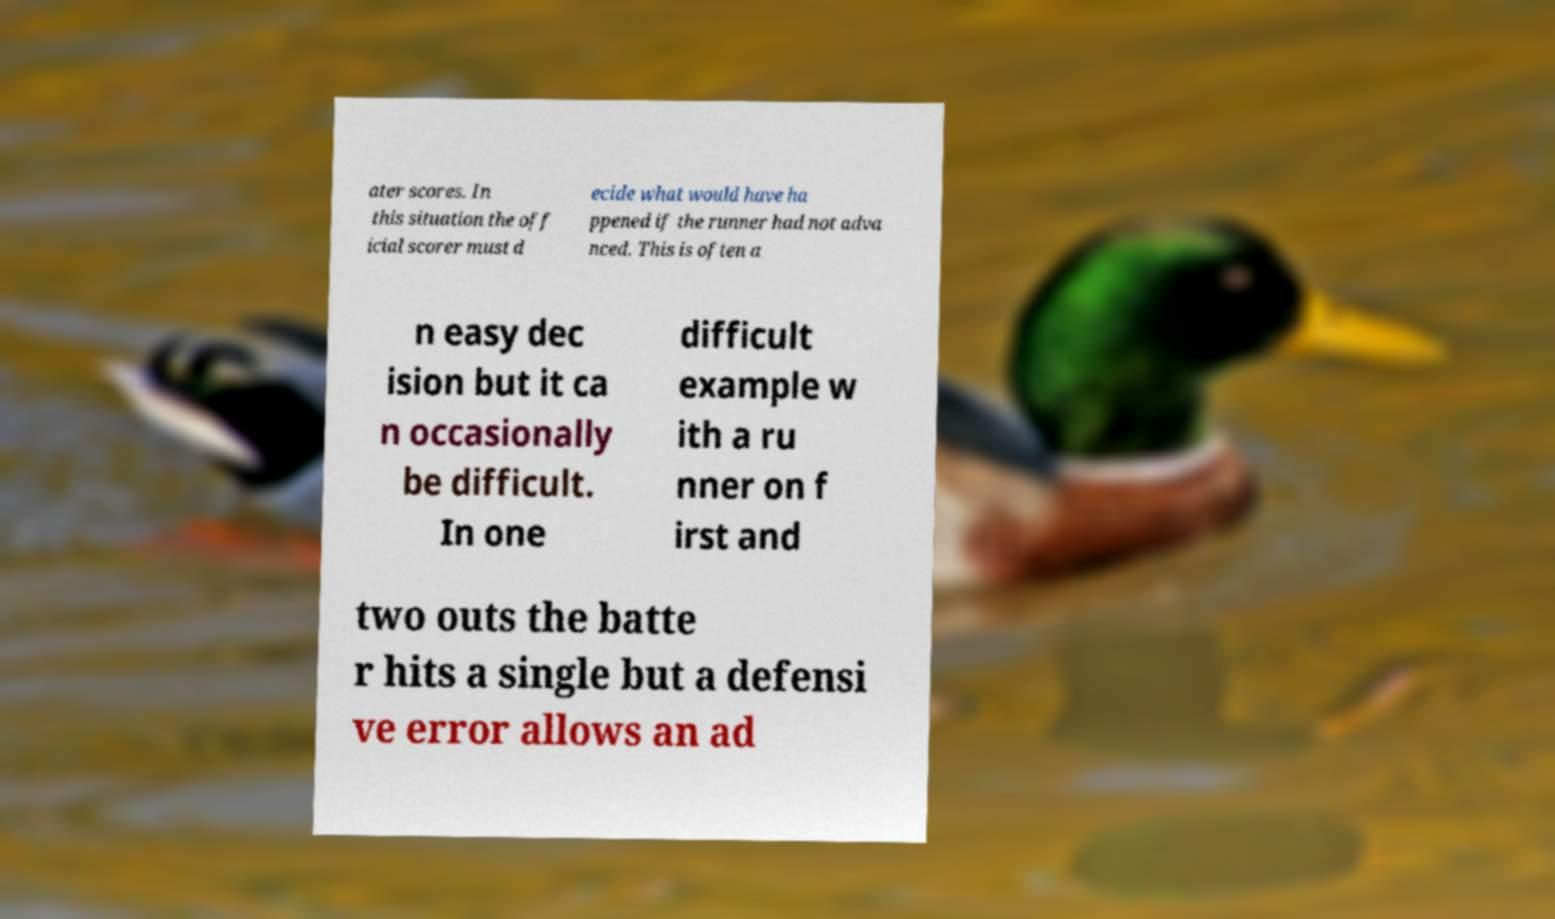Could you extract and type out the text from this image? ater scores. In this situation the off icial scorer must d ecide what would have ha ppened if the runner had not adva nced. This is often a n easy dec ision but it ca n occasionally be difficult. In one difficult example w ith a ru nner on f irst and two outs the batte r hits a single but a defensi ve error allows an ad 